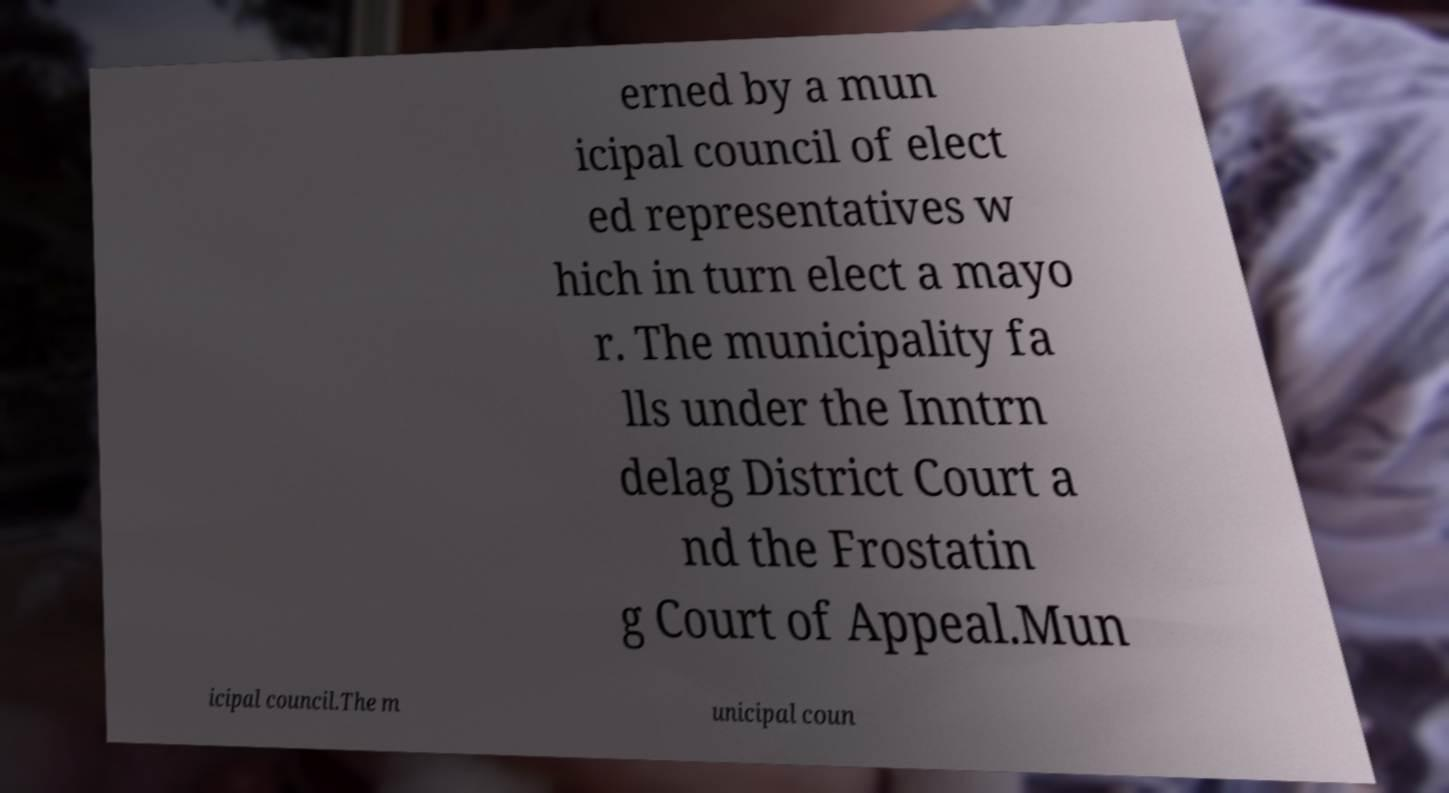Could you extract and type out the text from this image? erned by a mun icipal council of elect ed representatives w hich in turn elect a mayo r. The municipality fa lls under the Inntrn delag District Court a nd the Frostatin g Court of Appeal.Mun icipal council.The m unicipal coun 